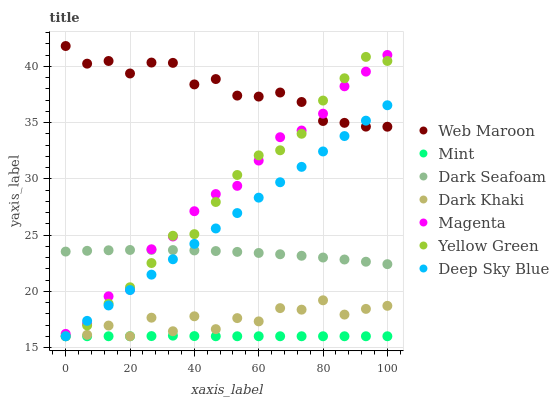Does Mint have the minimum area under the curve?
Answer yes or no. Yes. Does Web Maroon have the maximum area under the curve?
Answer yes or no. Yes. Does Dark Khaki have the minimum area under the curve?
Answer yes or no. No. Does Dark Khaki have the maximum area under the curve?
Answer yes or no. No. Is Deep Sky Blue the smoothest?
Answer yes or no. Yes. Is Dark Khaki the roughest?
Answer yes or no. Yes. Is Web Maroon the smoothest?
Answer yes or no. No. Is Web Maroon the roughest?
Answer yes or no. No. Does Yellow Green have the lowest value?
Answer yes or no. Yes. Does Web Maroon have the lowest value?
Answer yes or no. No. Does Web Maroon have the highest value?
Answer yes or no. Yes. Does Dark Khaki have the highest value?
Answer yes or no. No. Is Dark Khaki less than Magenta?
Answer yes or no. Yes. Is Web Maroon greater than Dark Seafoam?
Answer yes or no. Yes. Does Dark Seafoam intersect Deep Sky Blue?
Answer yes or no. Yes. Is Dark Seafoam less than Deep Sky Blue?
Answer yes or no. No. Is Dark Seafoam greater than Deep Sky Blue?
Answer yes or no. No. Does Dark Khaki intersect Magenta?
Answer yes or no. No. 